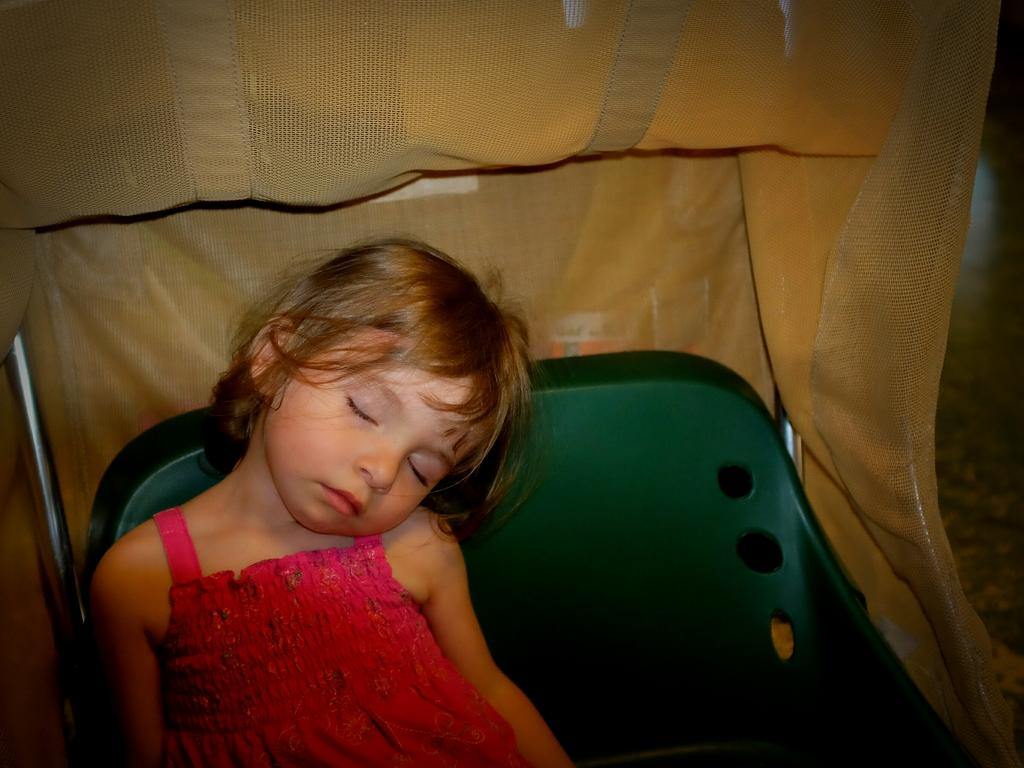Who is the main subject in the image? There is a girl in the image. What is the girl wearing? The girl is wearing clothes. What is the girl doing in the image? The girl is sleeping. What is the girl sitting or lying on in the image? There is a seat in the image. What type of material is visible in the image? There is cloth visible in the image. What is the surface beneath the girl and the seat? There is a floor in the image. What time of day is the girl's friend bringing her a glass of milk in the image? There is no friend or glass of milk present in the image. 